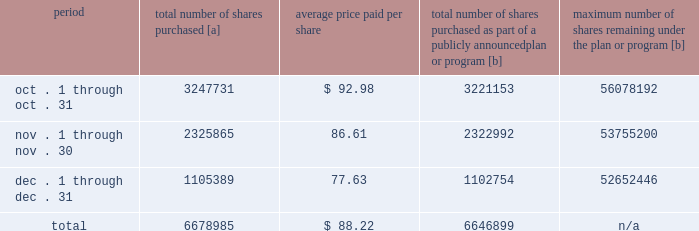Five-year performance comparison 2013 the following graph provides an indicator of cumulative total shareholder returns for the corporation as compared to the peer group index ( described above ) , the dj trans , and the s&p 500 .
The graph assumes that $ 100 was invested in the common stock of union pacific corporation and each index on december 31 , 2010 and that all dividends were reinvested .
The information below is historical in nature and is not necessarily indicative of future performance .
Purchases of equity securities 2013 during 2015 , we repurchased 36921641 shares of our common stock at an average price of $ 99.16 .
The table presents common stock repurchases during each month for the fourth quarter of 2015 : period total number of shares purchased [a] average price paid per share total number of shares purchased as part of a publicly announced plan or program [b] maximum number of shares remaining under the plan or program [b] .
[a] total number of shares purchased during the quarter includes approximately 32086 shares delivered or attested to upc by employees to pay stock option exercise prices , satisfy excess tax withholding obligations for stock option exercises or vesting of retention units , and pay withholding obligations for vesting of retention shares .
[b] effective january 1 , 2014 , our board of directors authorized the repurchase of up to 120 million shares of our common stock by december 31 , 2017 .
These repurchases may be made on the open market or through other transactions .
Our management has sole discretion with respect to determining the timing and amount of these transactions. .
What percentage of total shares purchased were purchased in december? 
Computations: (1105389 / 6678985)
Answer: 0.1655. 